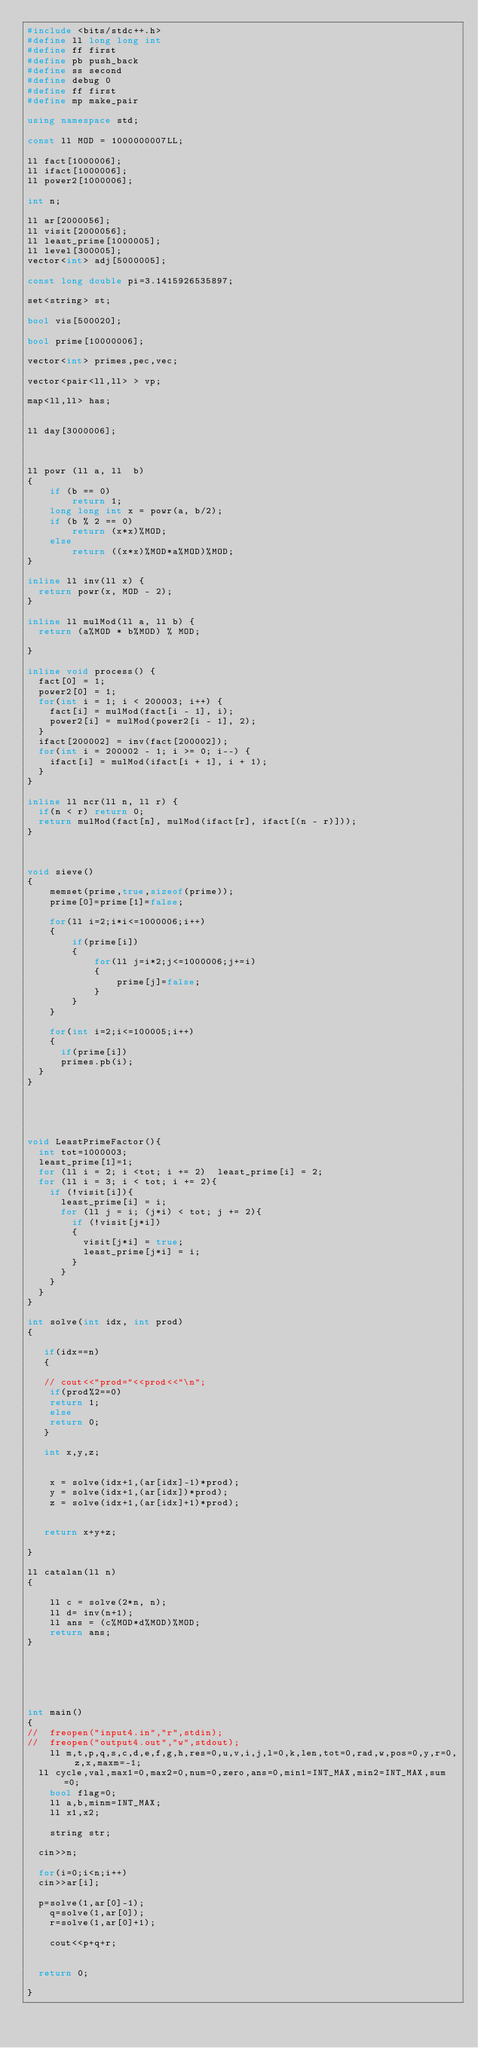<code> <loc_0><loc_0><loc_500><loc_500><_C++_>#include <bits/stdc++.h>
#define ll long long int
#define ff first
#define pb push_back
#define ss second
#define debug 0
#define ff first
#define mp make_pair
 
using namespace std;
 
const ll MOD = 1000000007LL;
 
ll fact[1000006];
ll ifact[1000006];
ll power2[1000006];

int n;
 
ll ar[2000056];
ll visit[2000056];
ll least_prime[1000005];
ll level[300005];
vector<int> adj[5000005];

const long double pi=3.1415926535897;

set<string> st;
 
bool vis[500020];
 
bool prime[10000006];
 
vector<int> primes,pec,vec;

vector<pair<ll,ll> > vp;

map<ll,ll> has;


ll day[3000006];
 
 
 
ll powr (ll a, ll  b)
{
    if (b == 0)
        return 1;
    long long int x = powr(a, b/2);
    if (b % 2 == 0)
        return (x*x)%MOD;
    else
        return ((x*x)%MOD*a%MOD)%MOD;
}
 
inline ll inv(ll x) {
  return powr(x, MOD - 2);
}
 
inline ll mulMod(ll a, ll b) {
  return (a%MOD * b%MOD) % MOD;
 
}
 
inline void process() {
  fact[0] = 1;
  power2[0] = 1;
  for(int i = 1; i < 200003; i++) {
    fact[i] = mulMod(fact[i - 1], i);
    power2[i] = mulMod(power2[i - 1], 2);
  }
  ifact[200002] = inv(fact[200002]);
  for(int i = 200002 - 1; i >= 0; i--) {
    ifact[i] = mulMod(ifact[i + 1], i + 1);
  }
}
 
inline ll ncr(ll n, ll r) {
  if(n < r) return 0;
  return mulMod(fact[n], mulMod(ifact[r], ifact[(n - r)]));
}
 
 
 
void sieve()
{
    memset(prime,true,sizeof(prime));
    prime[0]=prime[1]=false;
    
    for(ll i=2;i*i<=1000006;i++)
    {
        if(prime[i])
        {
            for(ll j=i*2;j<=1000006;j+=i)
            {
                prime[j]=false;
            }
        }
    }
    
    for(int i=2;i<=100005;i++)
    {
    	if(prime[i])
    	primes.pb(i);
	}
}





void LeastPrimeFactor(){
	int tot=1000003;
	least_prime[1]=1;
	for (ll i = 2; i <tot; i += 2)	least_prime[i] = 2;
	for (ll i = 3; i < tot; i += 2){
		if (!visit[i]){
			least_prime[i] = i;
			for (ll j = i; (j*i) < tot; j += 2){
				if (!visit[j*i])
				{
					visit[j*i] = true;
					least_prime[j*i] = i;
				}
			}
		}
	}
}

int solve(int idx, int prod)
{
   
   if(idx==n)
   {
   	
   //	cout<<"prod="<<prod<<"\n";
   	if(prod%2==0)
   	return 1;
   	else
   	return 0;
   }
   
   int x,y,z;
   
   
    x = solve(idx+1,(ar[idx]-1)*prod);
    y = solve(idx+1,(ar[idx])*prod);
    z = solve(idx+1,(ar[idx]+1)*prod);

   
   return x+y+z;
  
}
  
ll catalan(ll n)
{
   
    ll c = solve(2*n, n);
    ll d= inv(n+1);
    ll ans = (c%MOD*d%MOD)%MOD;
    return ans;
}




 

int main() 
{
//	freopen("input4.in","r",stdin);
//	freopen("output4.out","w",stdout);
    ll m,t,p,q,s,c,d,e,f,g,h,res=0,u,v,i,j,l=0,k,len,tot=0,rad,w,pos=0,y,r=0,z,x,maxm=-1;
	ll cycle,val,max1=0,max2=0,num=0,zero,ans=0,min1=INT_MAX,min2=INT_MAX,sum=0;
    bool flag=0;
    ll a,b,minm=INT_MAX;
    ll x1,x2;
    
    string str;
    
	cin>>n;
	
	for(i=0;i<n;i++)
	cin>>ar[i];
	
	p=solve(1,ar[0]-1);
    q=solve(1,ar[0]);
    r=solve(1,ar[0]+1);
    
    cout<<p+q+r;
	
    
	return 0;
    
}    </code> 